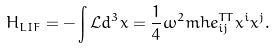<formula> <loc_0><loc_0><loc_500><loc_500>H _ { L I F } = - \int { \mathcal { L } } d ^ { 3 } x = \frac { 1 } { 4 } \omega ^ { 2 } m h e ^ { T T } _ { i j } x ^ { i } x ^ { j } .</formula> 